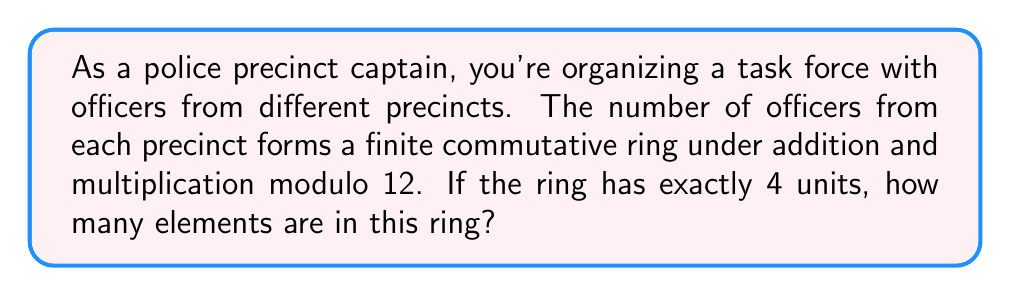Solve this math problem. Let's approach this step-by-step:

1) In a finite commutative ring with modulo 12 operation, the elements are $\{0, 1, 2, ..., 11\}$.

2) A unit in a ring is an element that has a multiplicative inverse. In other words, if $a$ is a unit, there exists a $b$ such that $ab \equiv 1 \pmod{12}$.

3) To find the units, we need to check which elements have a multiplicative inverse modulo 12:

   $1 \cdot 1 \equiv 1 \pmod{12}$
   $5 \cdot 5 \equiv 1 \pmod{12}$
   $7 \cdot 7 \equiv 1 \pmod{12}$
   $11 \cdot 11 \equiv 1 \pmod{12}$

4) Thus, the units in this ring are $\{1, 5, 7, 11\}$.

5) The question states that there are exactly 4 units, which matches our finding. This confirms that we're dealing with the ring of integers modulo 12, $\mathbb{Z}_{12}$.

6) In $\mathbb{Z}_{12}$, all elements $\{0, 1, 2, ..., 11\}$ are present.

7) Therefore, the total number of elements in this ring is 12.
Answer: The ring has 12 elements. 